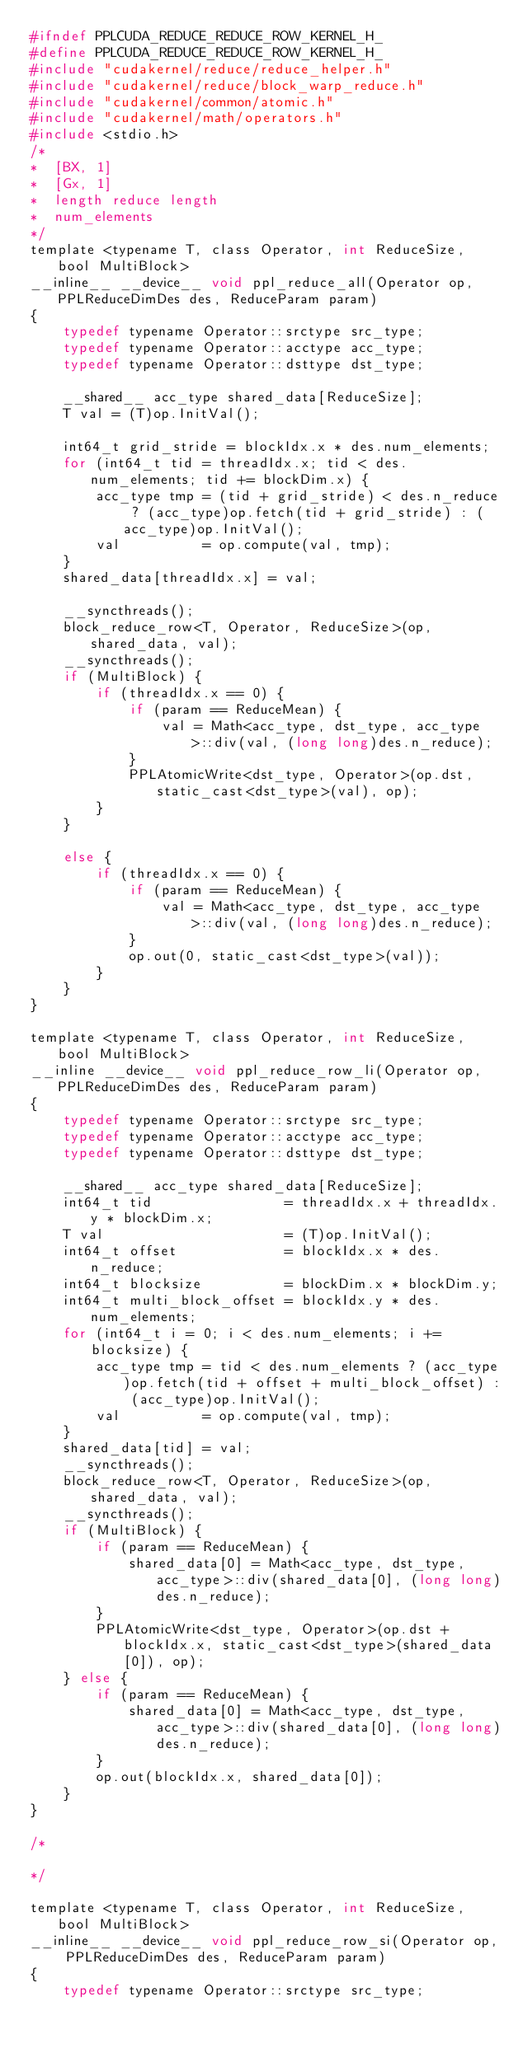<code> <loc_0><loc_0><loc_500><loc_500><_C_>#ifndef PPLCUDA_REDUCE_REDUCE_ROW_KERNEL_H_
#define PPLCUDA_REDUCE_REDUCE_ROW_KERNEL_H_
#include "cudakernel/reduce/reduce_helper.h"
#include "cudakernel/reduce/block_warp_reduce.h"
#include "cudakernel/common/atomic.h"
#include "cudakernel/math/operators.h"
#include <stdio.h>
/*
*  [BX, 1]
*  [Gx, 1] 
*  length reduce length
*  num_elements
*/
template <typename T, class Operator, int ReduceSize, bool MultiBlock>
__inline__ __device__ void ppl_reduce_all(Operator op, PPLReduceDimDes des, ReduceParam param)
{
    typedef typename Operator::srctype src_type;
    typedef typename Operator::acctype acc_type;
    typedef typename Operator::dsttype dst_type;

    __shared__ acc_type shared_data[ReduceSize];
    T val = (T)op.InitVal();

    int64_t grid_stride = blockIdx.x * des.num_elements;
    for (int64_t tid = threadIdx.x; tid < des.num_elements; tid += blockDim.x) {
        acc_type tmp = (tid + grid_stride) < des.n_reduce ? (acc_type)op.fetch(tid + grid_stride) : (acc_type)op.InitVal();
        val          = op.compute(val, tmp);
    }
    shared_data[threadIdx.x] = val;

    __syncthreads();
    block_reduce_row<T, Operator, ReduceSize>(op, shared_data, val);
    __syncthreads();
    if (MultiBlock) {
        if (threadIdx.x == 0) {
            if (param == ReduceMean) {
                val = Math<acc_type, dst_type, acc_type>::div(val, (long long)des.n_reduce);
            }
            PPLAtomicWrite<dst_type, Operator>(op.dst, static_cast<dst_type>(val), op);
        }
    }

    else {
        if (threadIdx.x == 0) {
            if (param == ReduceMean) {
                val = Math<acc_type, dst_type, acc_type>::div(val, (long long)des.n_reduce);
            }
            op.out(0, static_cast<dst_type>(val));
        }
    }
}

template <typename T, class Operator, int ReduceSize, bool MultiBlock>
__inline __device__ void ppl_reduce_row_li(Operator op, PPLReduceDimDes des, ReduceParam param)
{
    typedef typename Operator::srctype src_type;
    typedef typename Operator::acctype acc_type;
    typedef typename Operator::dsttype dst_type;

    __shared__ acc_type shared_data[ReduceSize];
    int64_t tid                = threadIdx.x + threadIdx.y * blockDim.x;
    T val                      = (T)op.InitVal();
    int64_t offset             = blockIdx.x * des.n_reduce;
    int64_t blocksize          = blockDim.x * blockDim.y;
    int64_t multi_block_offset = blockIdx.y * des.num_elements;
    for (int64_t i = 0; i < des.num_elements; i += blocksize) {
        acc_type tmp = tid < des.num_elements ? (acc_type)op.fetch(tid + offset + multi_block_offset) : (acc_type)op.InitVal();
        val          = op.compute(val, tmp);
    }
    shared_data[tid] = val;
    __syncthreads();
    block_reduce_row<T, Operator, ReduceSize>(op, shared_data, val);
    __syncthreads();
    if (MultiBlock) {
        if (param == ReduceMean) {
            shared_data[0] = Math<acc_type, dst_type, acc_type>::div(shared_data[0], (long long)des.n_reduce);
        }
        PPLAtomicWrite<dst_type, Operator>(op.dst + blockIdx.x, static_cast<dst_type>(shared_data[0]), op);
    } else {
        if (param == ReduceMean) {
            shared_data[0] = Math<acc_type, dst_type, acc_type>::div(shared_data[0], (long long)des.n_reduce);
        }
        op.out(blockIdx.x, shared_data[0]);
    }
}

/*

*/

template <typename T, class Operator, int ReduceSize, bool MultiBlock>
__inline__ __device__ void ppl_reduce_row_si(Operator op, PPLReduceDimDes des, ReduceParam param)
{
    typedef typename Operator::srctype src_type;</code> 